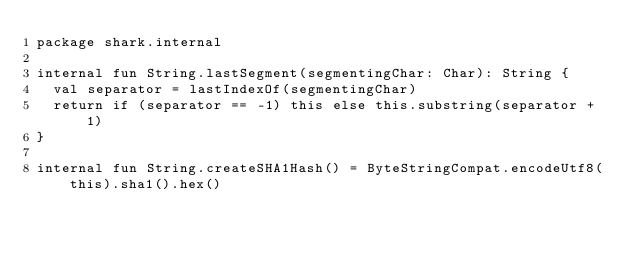<code> <loc_0><loc_0><loc_500><loc_500><_Kotlin_>package shark.internal

internal fun String.lastSegment(segmentingChar: Char): String {
  val separator = lastIndexOf(segmentingChar)
  return if (separator == -1) this else this.substring(separator + 1)
}

internal fun String.createSHA1Hash() = ByteStringCompat.encodeUtf8(this).sha1().hex()
</code> 